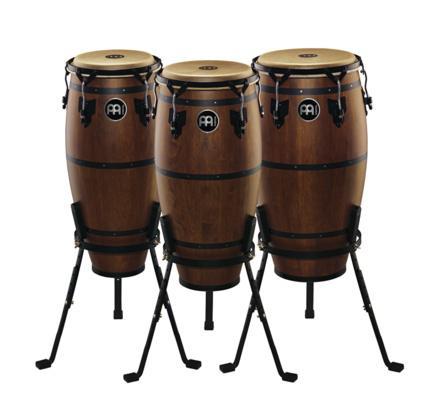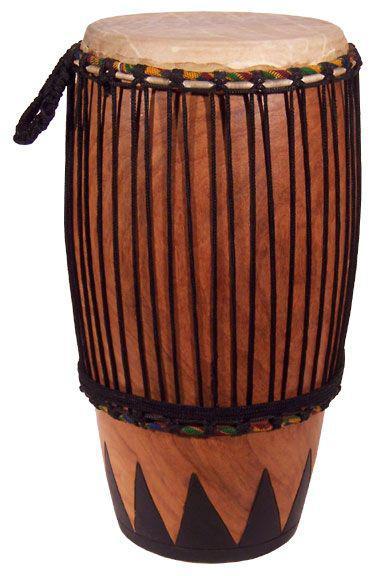The first image is the image on the left, the second image is the image on the right. Considering the images on both sides, is "One image shows a set of three congas and the other shows a single conga drum." valid? Answer yes or no. Yes. The first image is the image on the left, the second image is the image on the right. Given the left and right images, does the statement "The left image contains a neat row of three brown drums, and the right image features a single upright brown drum." hold true? Answer yes or no. Yes. 